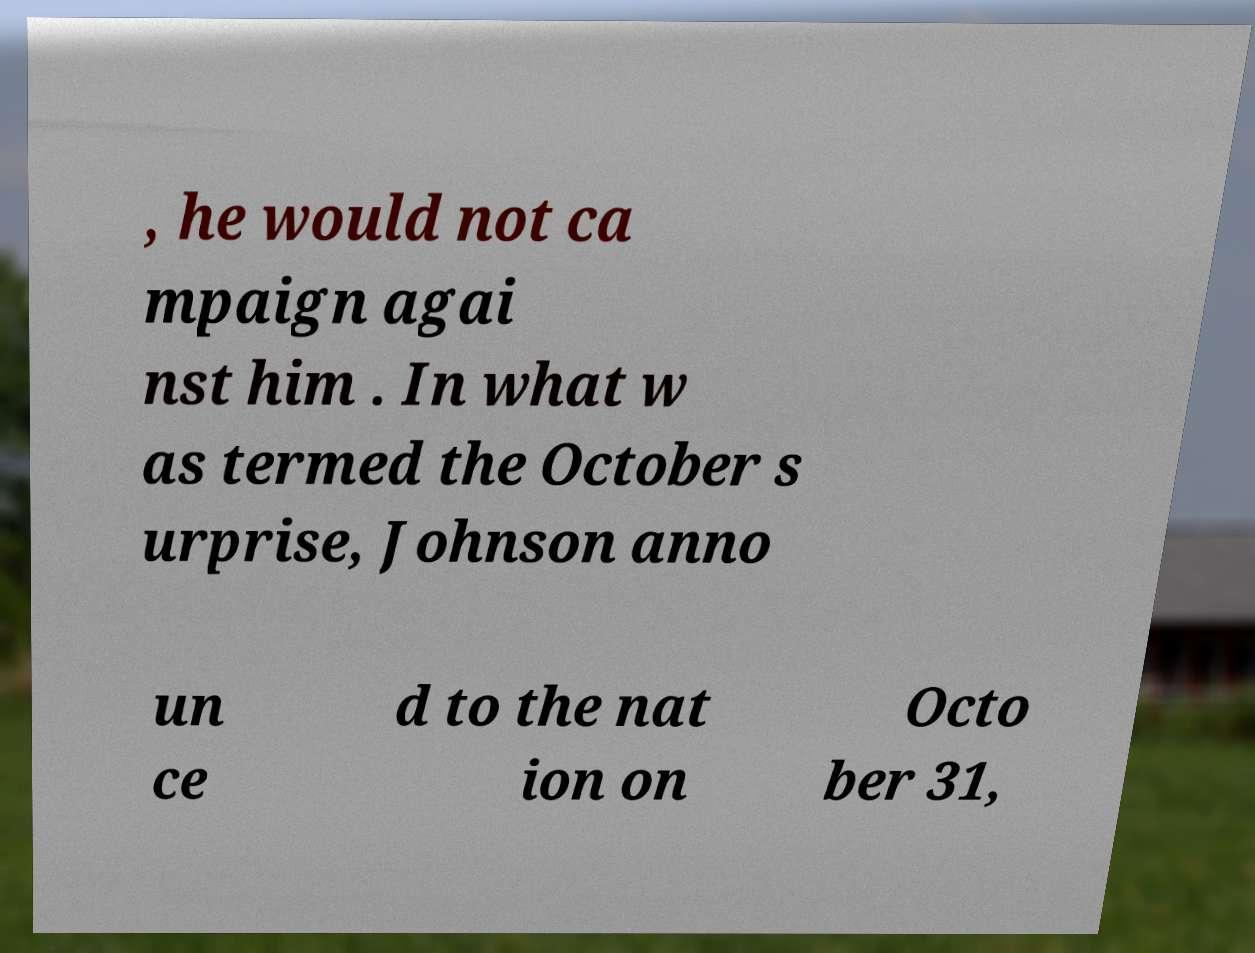What messages or text are displayed in this image? I need them in a readable, typed format. , he would not ca mpaign agai nst him . In what w as termed the October s urprise, Johnson anno un ce d to the nat ion on Octo ber 31, 